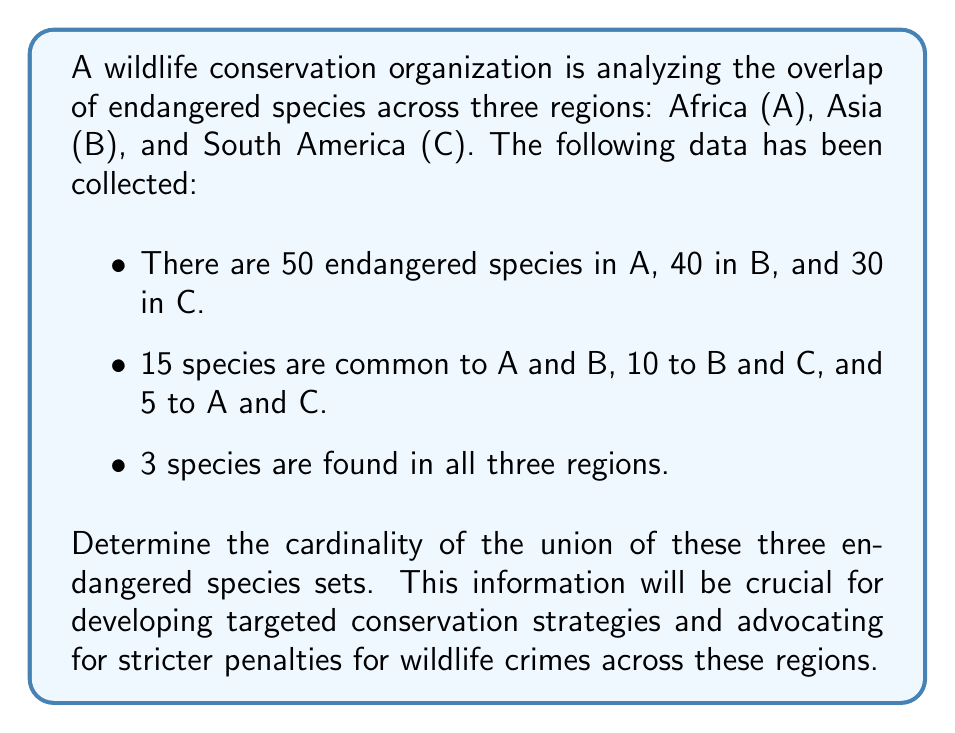Can you answer this question? To solve this problem, we'll use the Inclusion-Exclusion Principle for three sets:

$$|A \cup B \cup C| = |A| + |B| + |C| - |A \cap B| - |B \cap C| - |A \cap C| + |A \cap B \cap C|$$

Let's break down the information given:

1. $|A| = 50$, $|B| = 40$, $|C| = 30$
2. $|A \cap B| = 15$, $|B \cap C| = 10$, $|A \cap C| = 5$
3. $|A \cap B \cap C| = 3$

Now, let's substitute these values into the formula:

$$\begin{align*}
|A \cup B \cup C| &= |A| + |B| + |C| - |A \cap B| - |B \cap C| - |A \cap C| + |A \cap B \cap C| \\
&= 50 + 40 + 30 - 15 - 10 - 5 + 3 \\
&= 120 - 30 + 3 \\
&= 93
\end{align*}$$

This calculation gives us the total number of unique endangered species across all three regions, accounting for overlaps between the sets.
Answer: The cardinality of the union of the three endangered species sets is 93. 